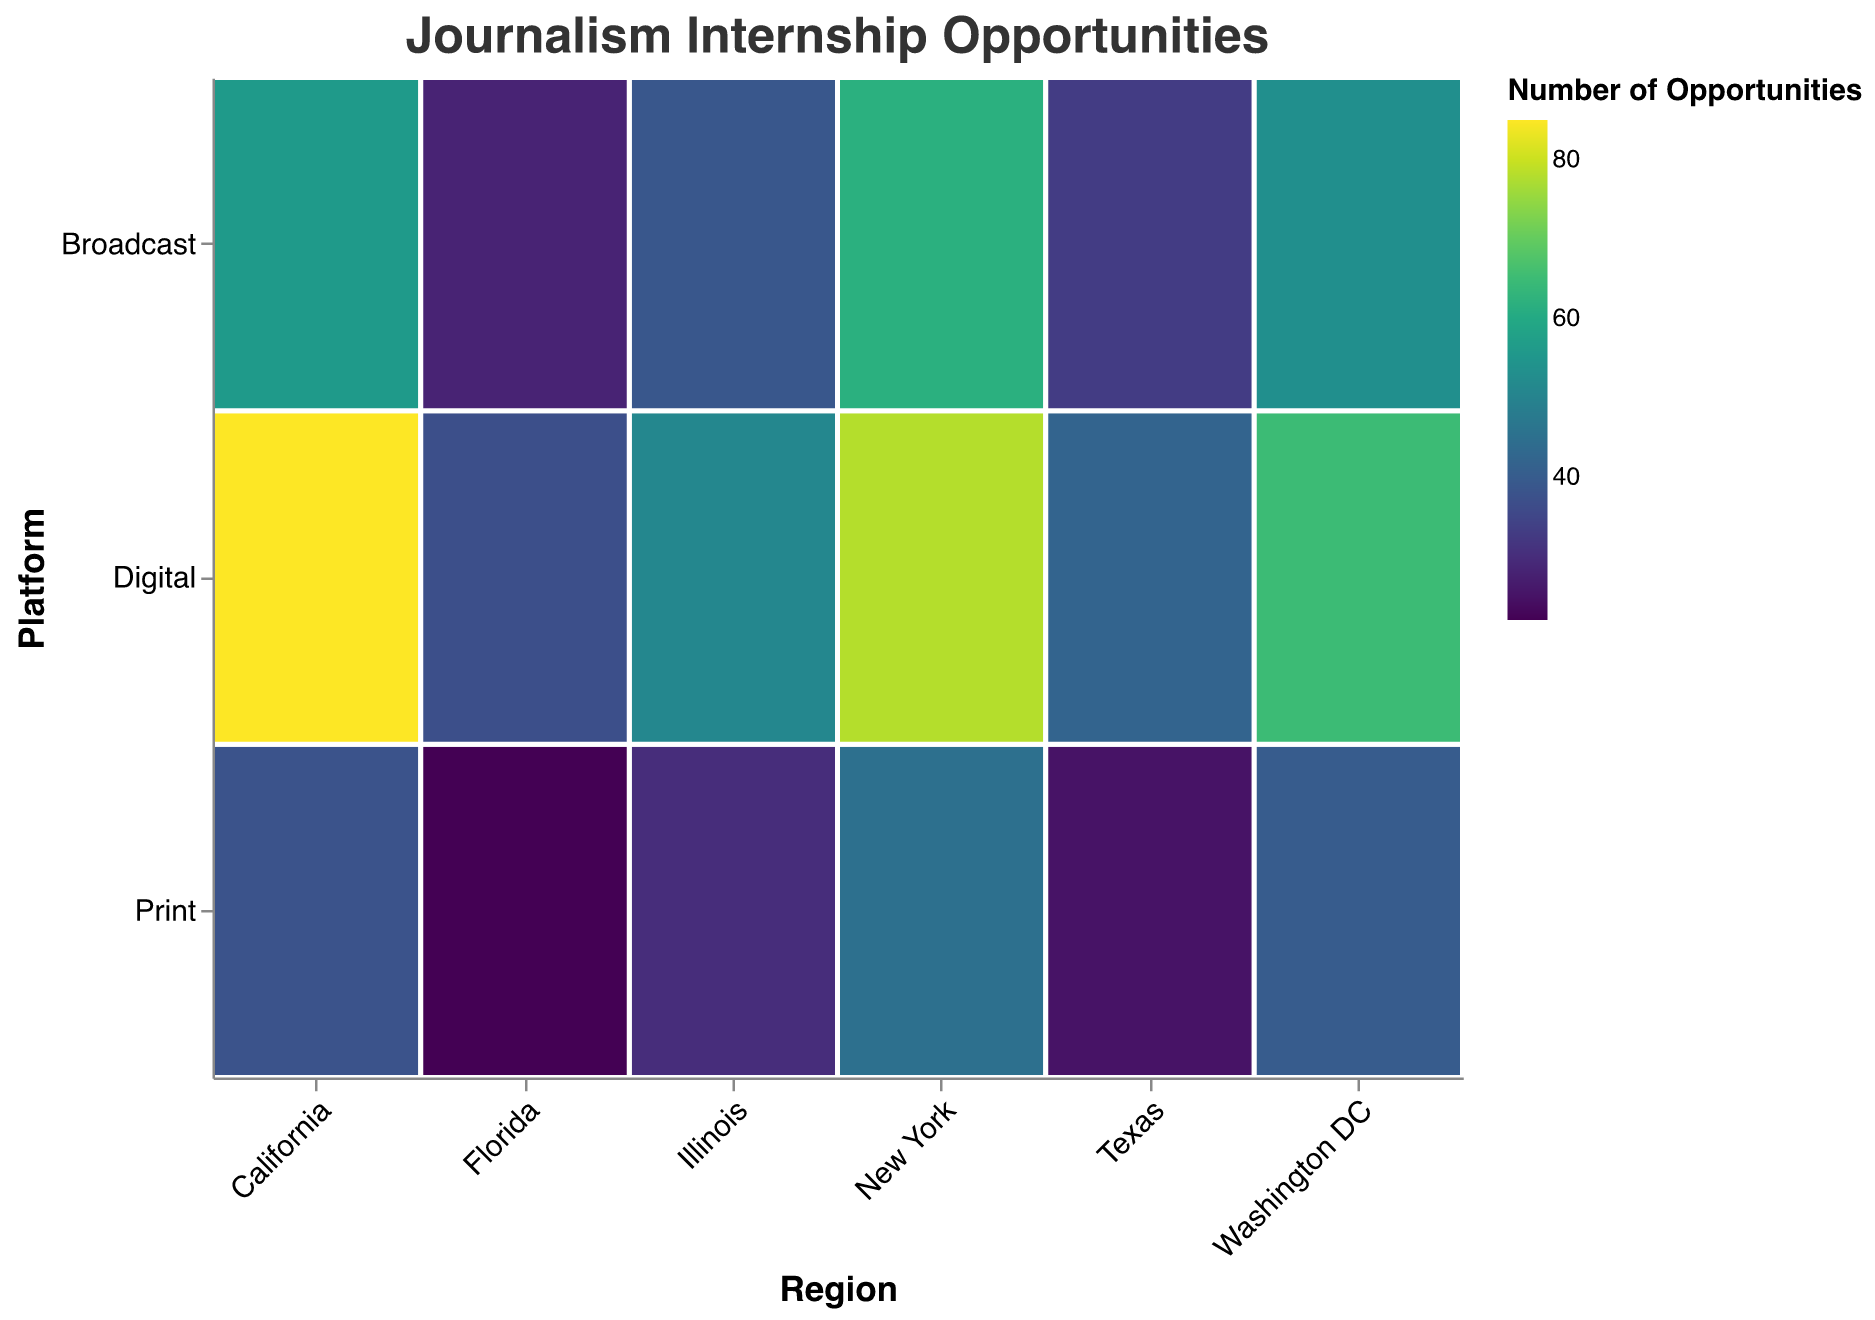What's the color scheme used in the figure? The figure uses the "viridis" color scheme to represent the number of opportunities, which is a gradient from light to dark colors.
Answer: Viridis What is the title of the mosaic plot? The title of the mosaic plot is "Journalism Internship Opportunities."
Answer: Journalism Internship Opportunities Which region has the most number of total internship opportunities? Adding up the opportunities in each platform for each region, New York has (45+78+62)=185, California has (38+85+56)=179, Texas has (25+42+33)=100, Illinois has (30+51+39)=120, Florida has (22+37+28)=87, and Washington DC has (40+65+53)=158. New York has the highest total with 185 opportunities.
Answer: New York How do internship opportunities in Digital platforms compare between New York and California? New York has 78 Digital internship opportunities, while California has 85. So, California has more Digital internship opportunities than New York.
Answer: California has more Which platform has the least number of opportunities in Texas? Comparing the opportunities in Texas, Print has 25, Digital has 42, and Broadcast has 33. Print has the least number of opportunities.
Answer: Print What is the average number of opportunities across all platforms in Illinois? Illinois has 30 (Print) + 51 (Digital) + 39 (Broadcast) = 120 total opportunities. The average is 120 / 3 = 40 opportunities.
Answer: 40 Which region has the highest number of Print opportunities? By examining each region's Print opportunities, New York has 45, California has 38, Texas has 25, Illinois has 30, Florida has 22, and Washington DC has 40. New York has the highest number of Print opportunities with 45.
Answer: New York How many opportunities are available in Washington DC in comparison to Texas across all platforms? Washington DC has 40 (Print) + 65 (Digital) + 53 (Broadcast) = 158 opportunities, while Texas has 25 (Print) + 42 (Digital) + 33 (Broadcast) = 100 opportunities. Washington DC has more opportunities compared to Texas.
Answer: Washington DC has more In which region do Digital platforms dominate the most compared to Print and Broadcast? For each region, compare the Digital opportunities to the sum of Print and Broadcast opportunities. New York: 78 vs (45+62)=107, California: 85 vs (38+56)=94, Texas: 42 vs (25+33)=58, Illinois: 51 vs (30+39)=69, Florida: 37 vs (22+28)=50, Washington DC: 65 vs (40+53)=93. In all regions, Digital opportunities are less than the sum of Print and Broadcast, but California has the smallest difference (85 vs 94), making it the region where Digital dominates most proportionally.
Answer: California 